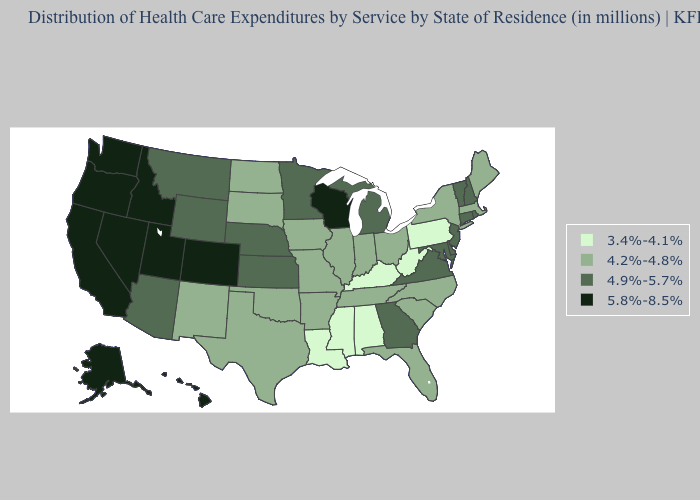What is the value of Iowa?
Answer briefly. 4.2%-4.8%. What is the highest value in states that border Vermont?
Answer briefly. 4.9%-5.7%. Is the legend a continuous bar?
Give a very brief answer. No. Name the states that have a value in the range 3.4%-4.1%?
Write a very short answer. Alabama, Kentucky, Louisiana, Mississippi, Pennsylvania, West Virginia. Among the states that border Ohio , does Indiana have the highest value?
Write a very short answer. No. Does the first symbol in the legend represent the smallest category?
Concise answer only. Yes. What is the value of New Mexico?
Keep it brief. 4.2%-4.8%. Name the states that have a value in the range 3.4%-4.1%?
Answer briefly. Alabama, Kentucky, Louisiana, Mississippi, Pennsylvania, West Virginia. Does Georgia have a lower value than Missouri?
Keep it brief. No. Name the states that have a value in the range 4.2%-4.8%?
Be succinct. Arkansas, Florida, Illinois, Indiana, Iowa, Maine, Massachusetts, Missouri, New Mexico, New York, North Carolina, North Dakota, Ohio, Oklahoma, South Carolina, South Dakota, Tennessee, Texas. Name the states that have a value in the range 4.9%-5.7%?
Be succinct. Arizona, Connecticut, Delaware, Georgia, Kansas, Maryland, Michigan, Minnesota, Montana, Nebraska, New Hampshire, New Jersey, Rhode Island, Vermont, Virginia, Wyoming. What is the value of North Carolina?
Concise answer only. 4.2%-4.8%. What is the value of Alaska?
Answer briefly. 5.8%-8.5%. Name the states that have a value in the range 4.9%-5.7%?
Be succinct. Arizona, Connecticut, Delaware, Georgia, Kansas, Maryland, Michigan, Minnesota, Montana, Nebraska, New Hampshire, New Jersey, Rhode Island, Vermont, Virginia, Wyoming. What is the value of Utah?
Concise answer only. 5.8%-8.5%. 